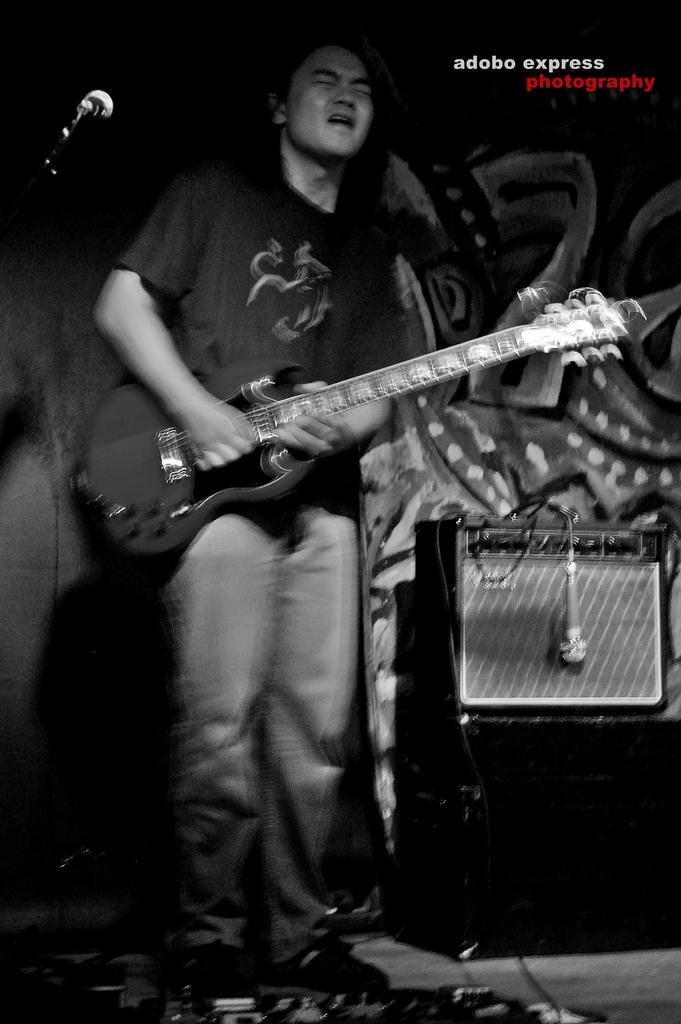What is the color scheme of the image? The image is black and white. Who is present in the image? There is a man in the image. What is the man doing in the image? The man is standing and playing a guitar. What can be seen hanging in the image? There is a microphone hanging in the image. Where is the speaker located in the image? The speaker is placed at the right corner of the image. What type of cloth is draped over the guitar in the image? There is no cloth draped over the guitar in the image; the guitar is visible without any covering. 